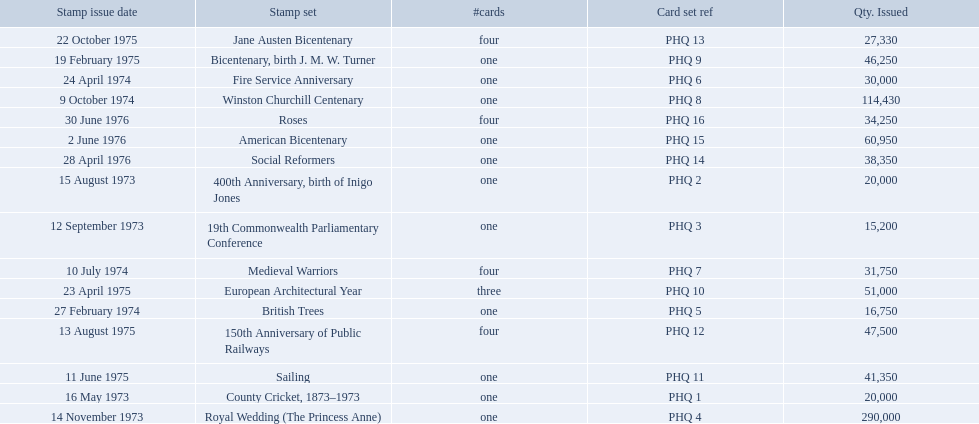What are all of the stamp sets? County Cricket, 1873–1973, 400th Anniversary, birth of Inigo Jones, 19th Commonwealth Parliamentary Conference, Royal Wedding (The Princess Anne), British Trees, Fire Service Anniversary, Medieval Warriors, Winston Churchill Centenary, Bicentenary, birth J. M. W. Turner, European Architectural Year, Sailing, 150th Anniversary of Public Railways, Jane Austen Bicentenary, Social Reformers, American Bicentenary, Roses. Which of these sets has three cards in it? European Architectural Year. 